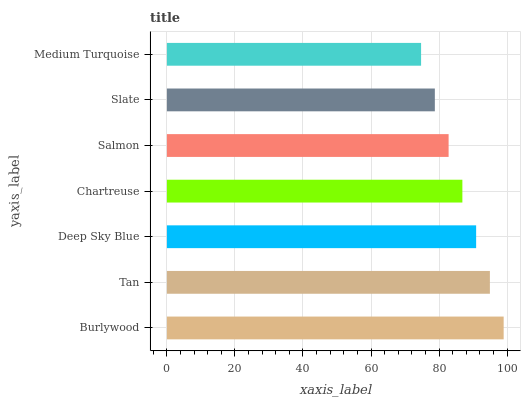Is Medium Turquoise the minimum?
Answer yes or no. Yes. Is Burlywood the maximum?
Answer yes or no. Yes. Is Tan the minimum?
Answer yes or no. No. Is Tan the maximum?
Answer yes or no. No. Is Burlywood greater than Tan?
Answer yes or no. Yes. Is Tan less than Burlywood?
Answer yes or no. Yes. Is Tan greater than Burlywood?
Answer yes or no. No. Is Burlywood less than Tan?
Answer yes or no. No. Is Chartreuse the high median?
Answer yes or no. Yes. Is Chartreuse the low median?
Answer yes or no. Yes. Is Deep Sky Blue the high median?
Answer yes or no. No. Is Burlywood the low median?
Answer yes or no. No. 